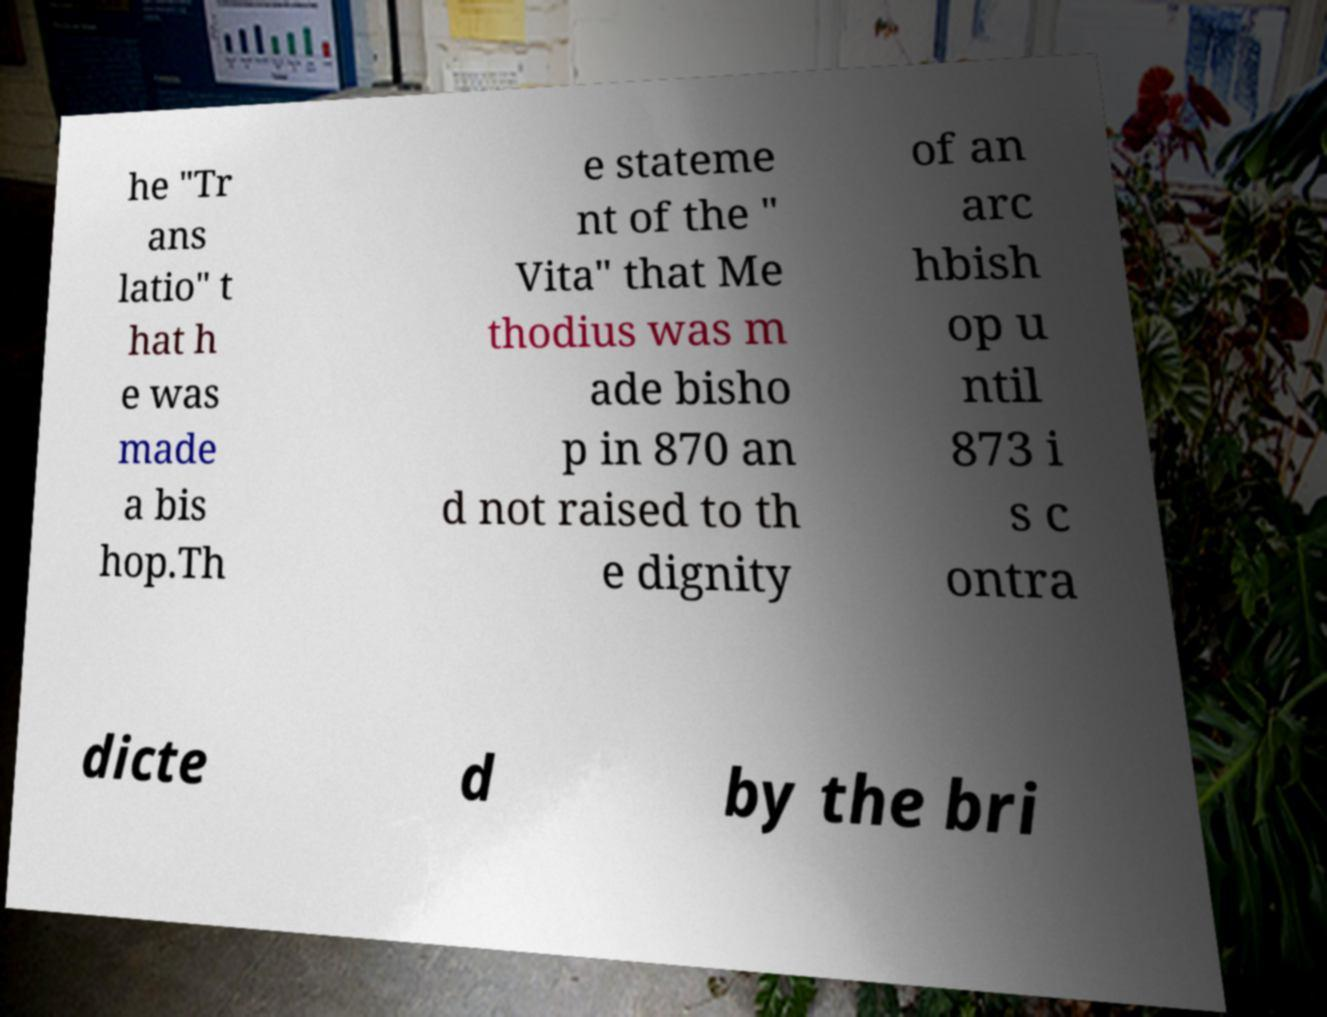Could you assist in decoding the text presented in this image and type it out clearly? he "Tr ans latio" t hat h e was made a bis hop.Th e stateme nt of the " Vita" that Me thodius was m ade bisho p in 870 an d not raised to th e dignity of an arc hbish op u ntil 873 i s c ontra dicte d by the bri 